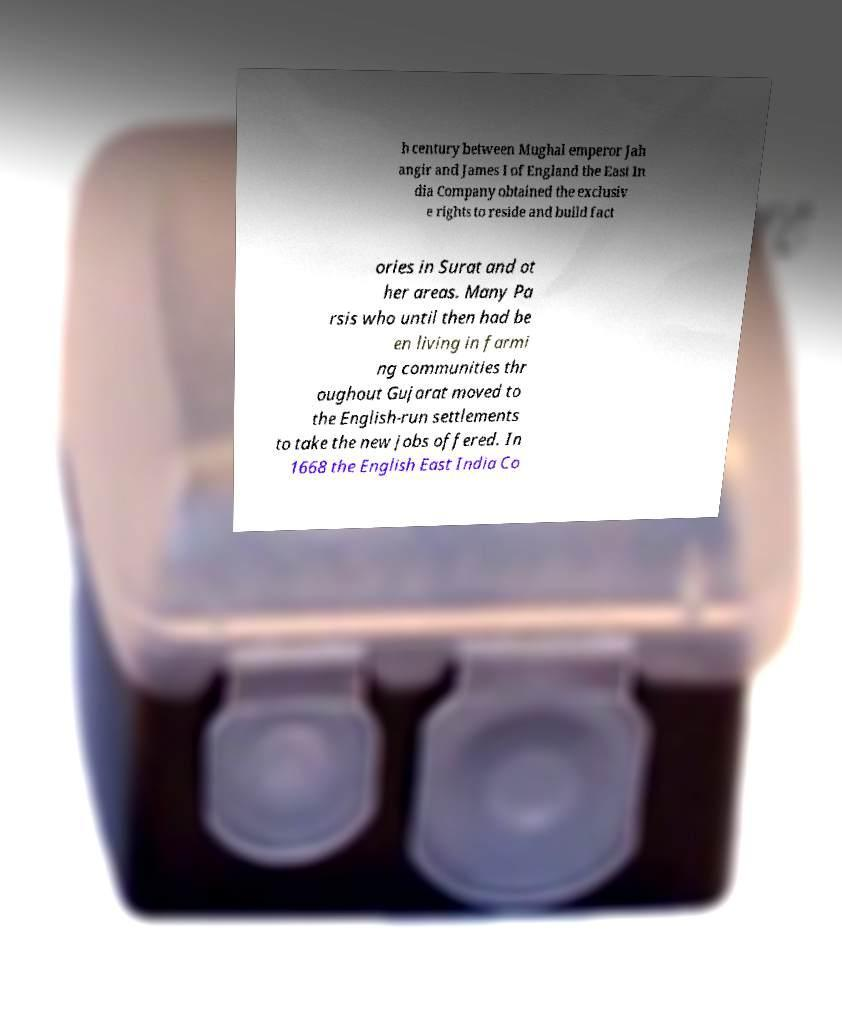Could you extract and type out the text from this image? h century between Mughal emperor Jah angir and James I of England the East In dia Company obtained the exclusiv e rights to reside and build fact ories in Surat and ot her areas. Many Pa rsis who until then had be en living in farmi ng communities thr oughout Gujarat moved to the English-run settlements to take the new jobs offered. In 1668 the English East India Co 